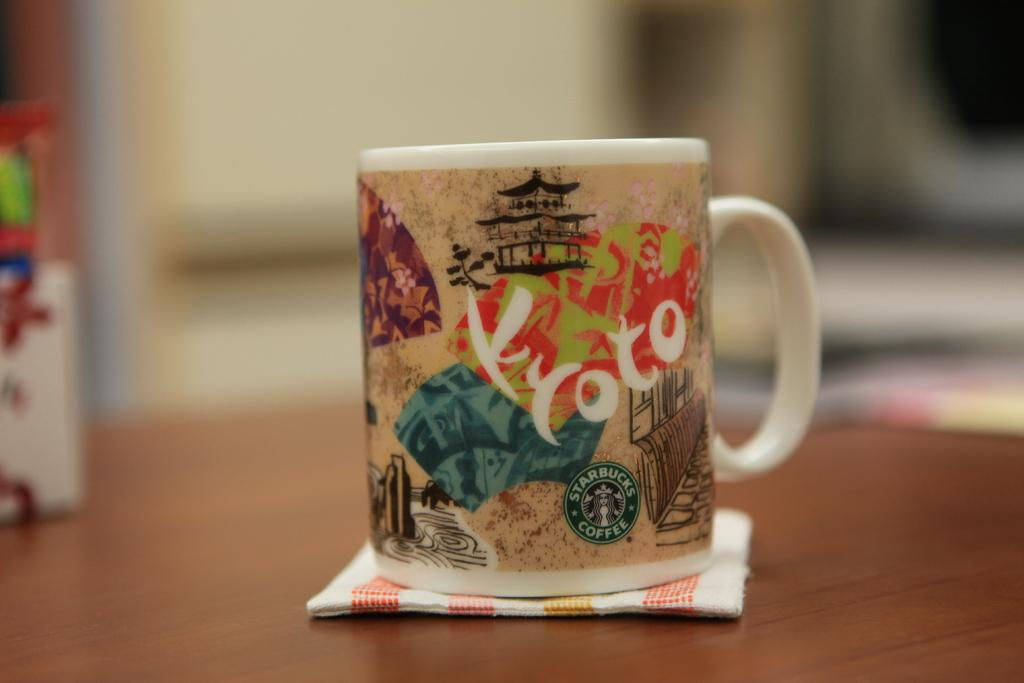What piece of furniture is visible in the image? There is a table in the image. What is placed on the table? A mug is placed on the table. Is there anything under the mug? Yes, there is a napkin under the mug. How many objects are placed on the table? There are three objects placed on the table. What can be said about the background of the image? The background of the image is blurred. What type of pest can be seen crawling on the table in the image? There is no pest visible in the image; the table and its contents are the only subjects present. 